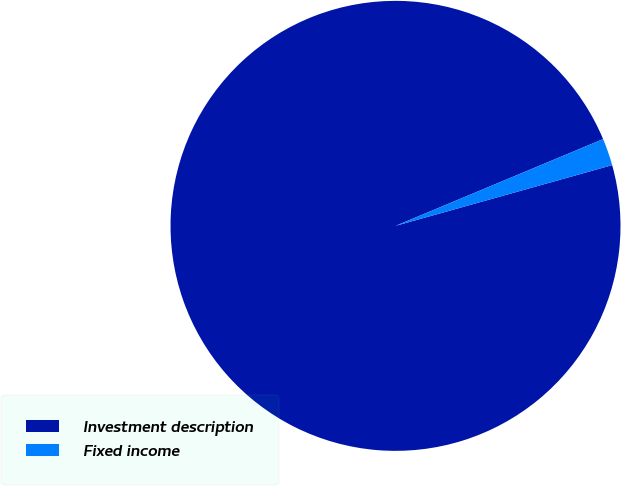Convert chart to OTSL. <chart><loc_0><loc_0><loc_500><loc_500><pie_chart><fcel>Investment description<fcel>Fixed income<nl><fcel>98.05%<fcel>1.95%<nl></chart> 